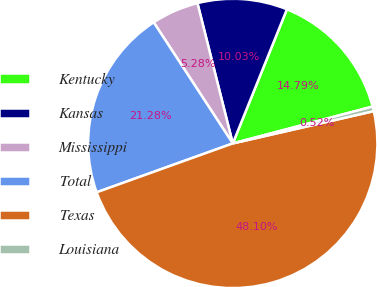Convert chart. <chart><loc_0><loc_0><loc_500><loc_500><pie_chart><fcel>Kentucky<fcel>Kansas<fcel>Mississippi<fcel>Total<fcel>Texas<fcel>Louisiana<nl><fcel>14.79%<fcel>10.03%<fcel>5.28%<fcel>21.28%<fcel>48.1%<fcel>0.52%<nl></chart> 